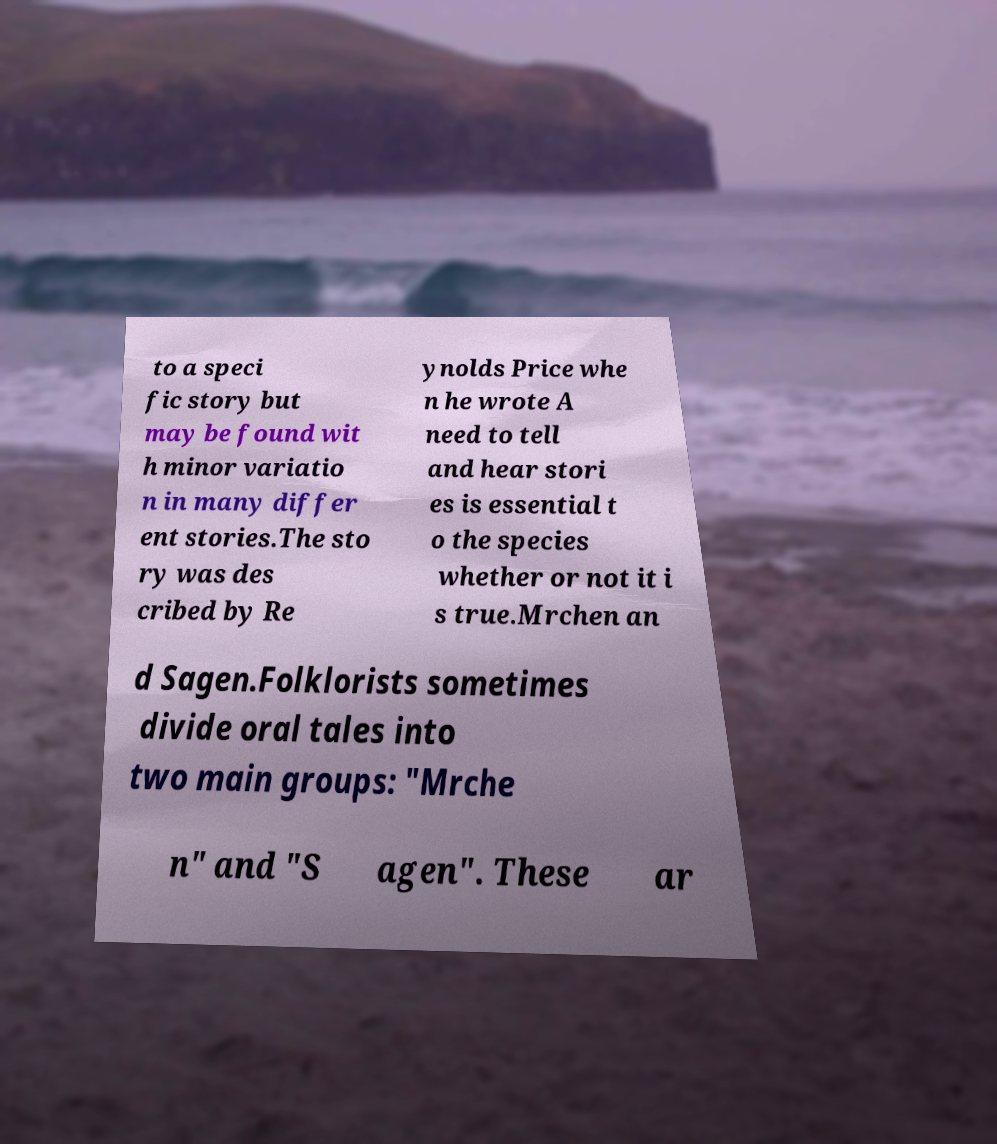Please identify and transcribe the text found in this image. to a speci fic story but may be found wit h minor variatio n in many differ ent stories.The sto ry was des cribed by Re ynolds Price whe n he wrote A need to tell and hear stori es is essential t o the species whether or not it i s true.Mrchen an d Sagen.Folklorists sometimes divide oral tales into two main groups: "Mrche n" and "S agen". These ar 